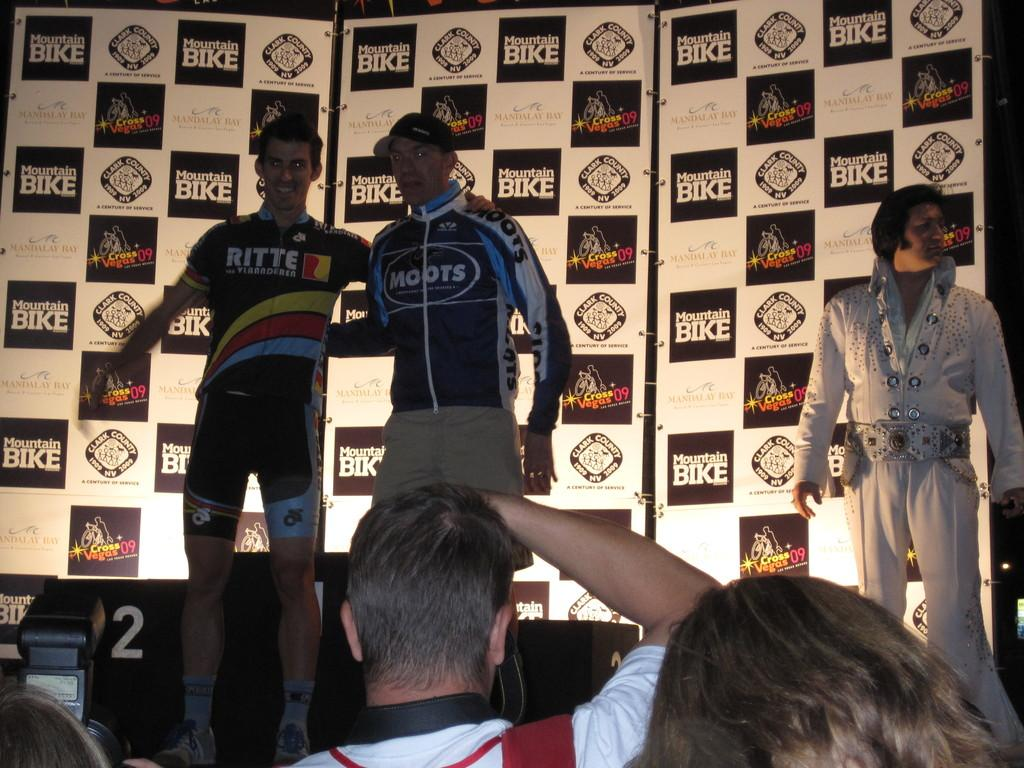<image>
Present a compact description of the photo's key features. Men standing on a stage with one wearing a jacket that says RITTE on it. 